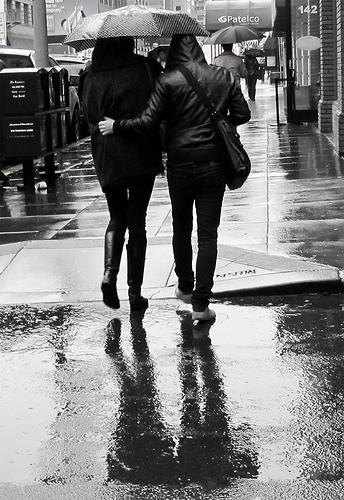What relationship do the persons sharing the umbrella have? lovers 